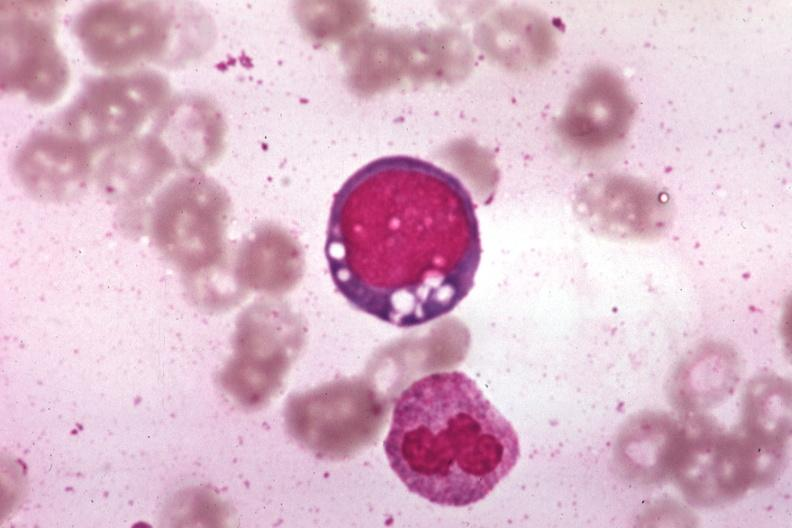s pierre robin sndrome present?
Answer the question using a single word or phrase. No 